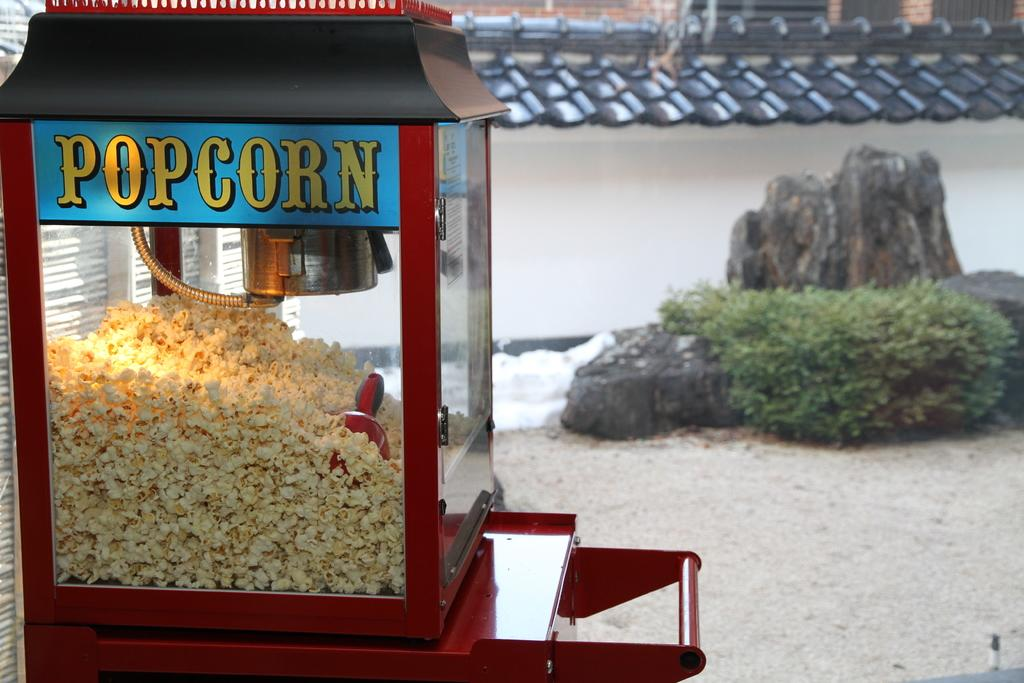<image>
Give a short and clear explanation of the subsequent image. a red glass machine that says 'popcorn' on it 